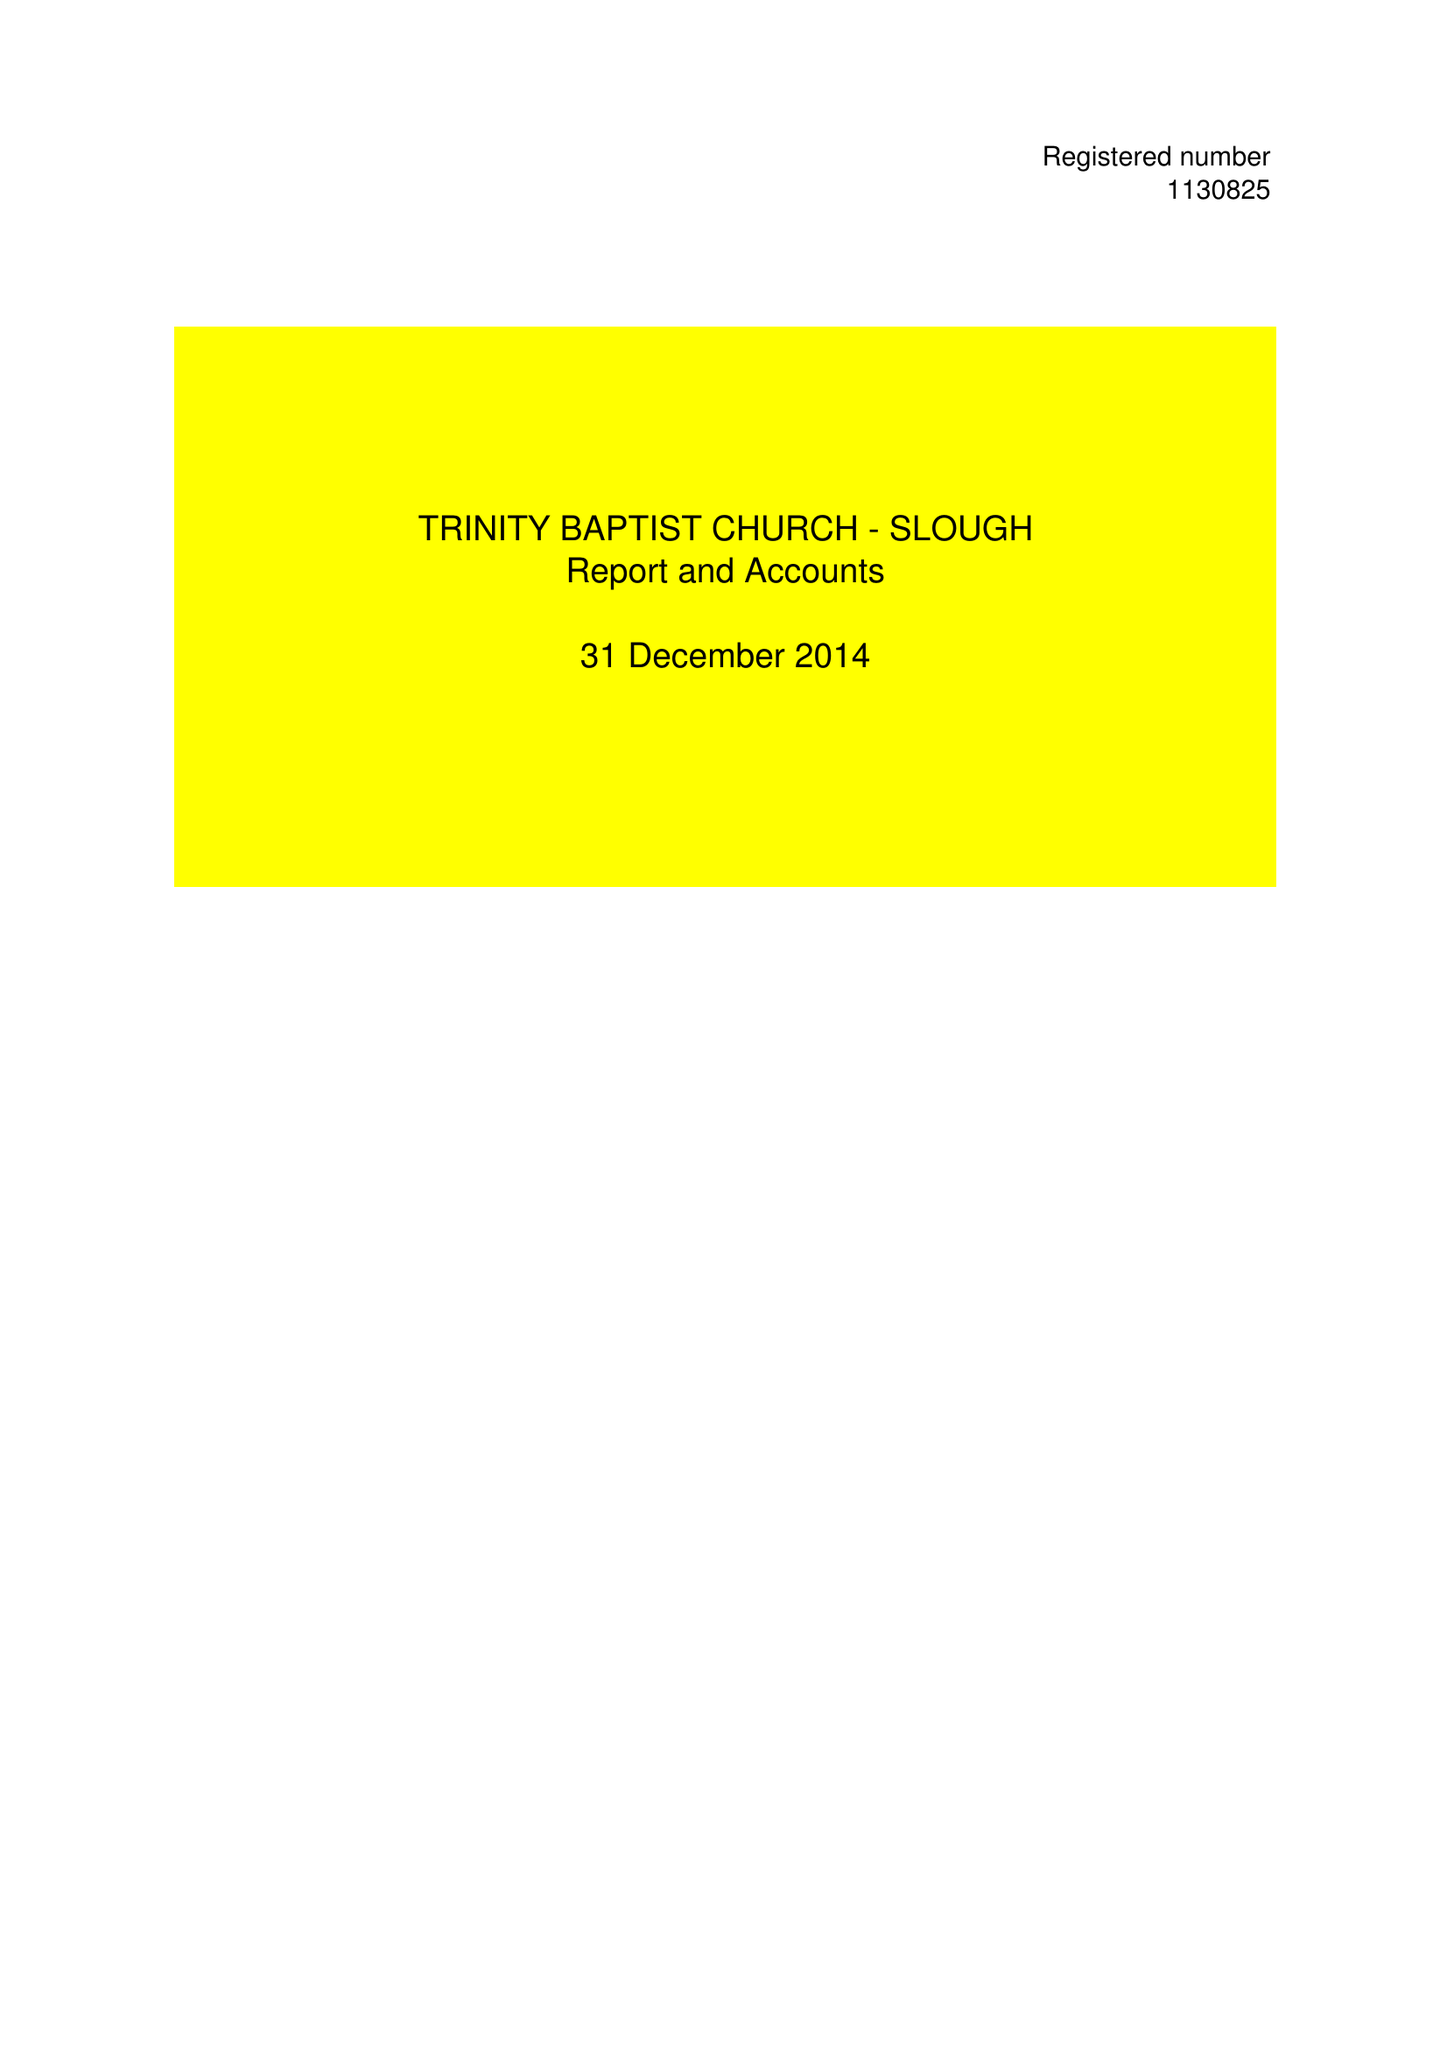What is the value for the spending_annually_in_british_pounds?
Answer the question using a single word or phrase. 56908.00 